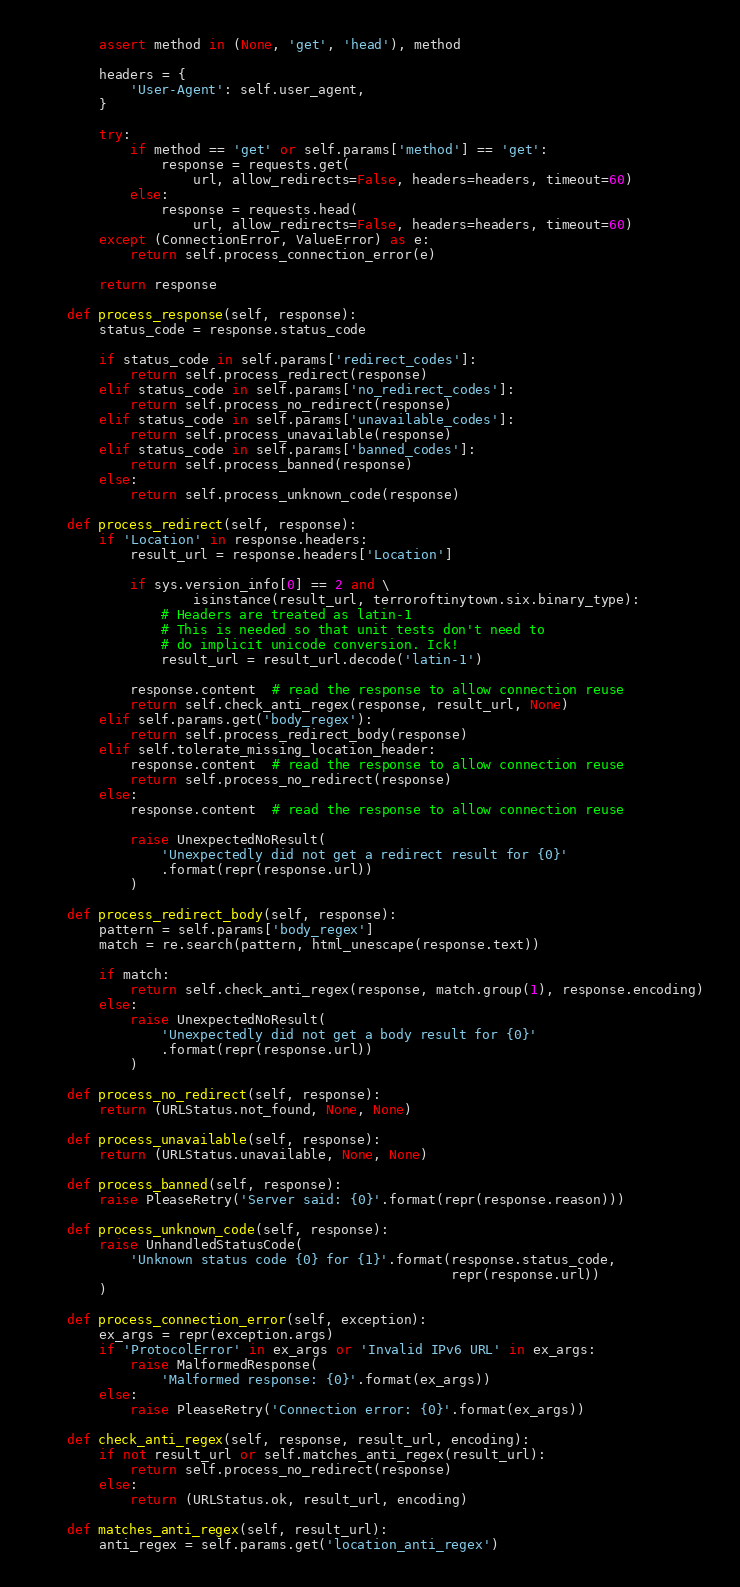Convert code to text. <code><loc_0><loc_0><loc_500><loc_500><_Python_>
        assert method in (None, 'get', 'head'), method

        headers = {
            'User-Agent': self.user_agent,
        }

        try:
            if method == 'get' or self.params['method'] == 'get':
                response = requests.get(
                    url, allow_redirects=False, headers=headers, timeout=60)
            else:
                response = requests.head(
                    url, allow_redirects=False, headers=headers, timeout=60)
        except (ConnectionError, ValueError) as e:
            return self.process_connection_error(e)

        return response

    def process_response(self, response):
        status_code = response.status_code

        if status_code in self.params['redirect_codes']:
            return self.process_redirect(response)
        elif status_code in self.params['no_redirect_codes']:
            return self.process_no_redirect(response)
        elif status_code in self.params['unavailable_codes']:
            return self.process_unavailable(response)
        elif status_code in self.params['banned_codes']:
            return self.process_banned(response)
        else:
            return self.process_unknown_code(response)

    def process_redirect(self, response):
        if 'Location' in response.headers:
            result_url = response.headers['Location']

            if sys.version_info[0] == 2 and \
                    isinstance(result_url, terroroftinytown.six.binary_type):
                # Headers are treated as latin-1
                # This is needed so that unit tests don't need to
                # do implicit unicode conversion. Ick!
                result_url = result_url.decode('latin-1')

            response.content  # read the response to allow connection reuse
            return self.check_anti_regex(response, result_url, None)
        elif self.params.get('body_regex'):
            return self.process_redirect_body(response)
        elif self.tolerate_missing_location_header:
            response.content  # read the response to allow connection reuse
            return self.process_no_redirect(response)
        else:
            response.content  # read the response to allow connection reuse

            raise UnexpectedNoResult(
                'Unexpectedly did not get a redirect result for {0}'
                .format(repr(response.url))
            )

    def process_redirect_body(self, response):
        pattern = self.params['body_regex']
        match = re.search(pattern, html_unescape(response.text))

        if match:
            return self.check_anti_regex(response, match.group(1), response.encoding)
        else:
            raise UnexpectedNoResult(
                'Unexpectedly did not get a body result for {0}'
                .format(repr(response.url))
            )

    def process_no_redirect(self, response):
        return (URLStatus.not_found, None, None)

    def process_unavailable(self, response):
        return (URLStatus.unavailable, None, None)

    def process_banned(self, response):
        raise PleaseRetry('Server said: {0}'.format(repr(response.reason)))

    def process_unknown_code(self, response):
        raise UnhandledStatusCode(
            'Unknown status code {0} for {1}'.format(response.status_code,
                                                     repr(response.url))
        )

    def process_connection_error(self, exception):
        ex_args = repr(exception.args)
        if 'ProtocolError' in ex_args or 'Invalid IPv6 URL' in ex_args:
            raise MalformedResponse(
                'Malformed response: {0}'.format(ex_args))
        else:
            raise PleaseRetry('Connection error: {0}'.format(ex_args))

    def check_anti_regex(self, response, result_url, encoding):
        if not result_url or self.matches_anti_regex(result_url):
            return self.process_no_redirect(response)
        else:
            return (URLStatus.ok, result_url, encoding)

    def matches_anti_regex(self, result_url):
        anti_regex = self.params.get('location_anti_regex')</code> 